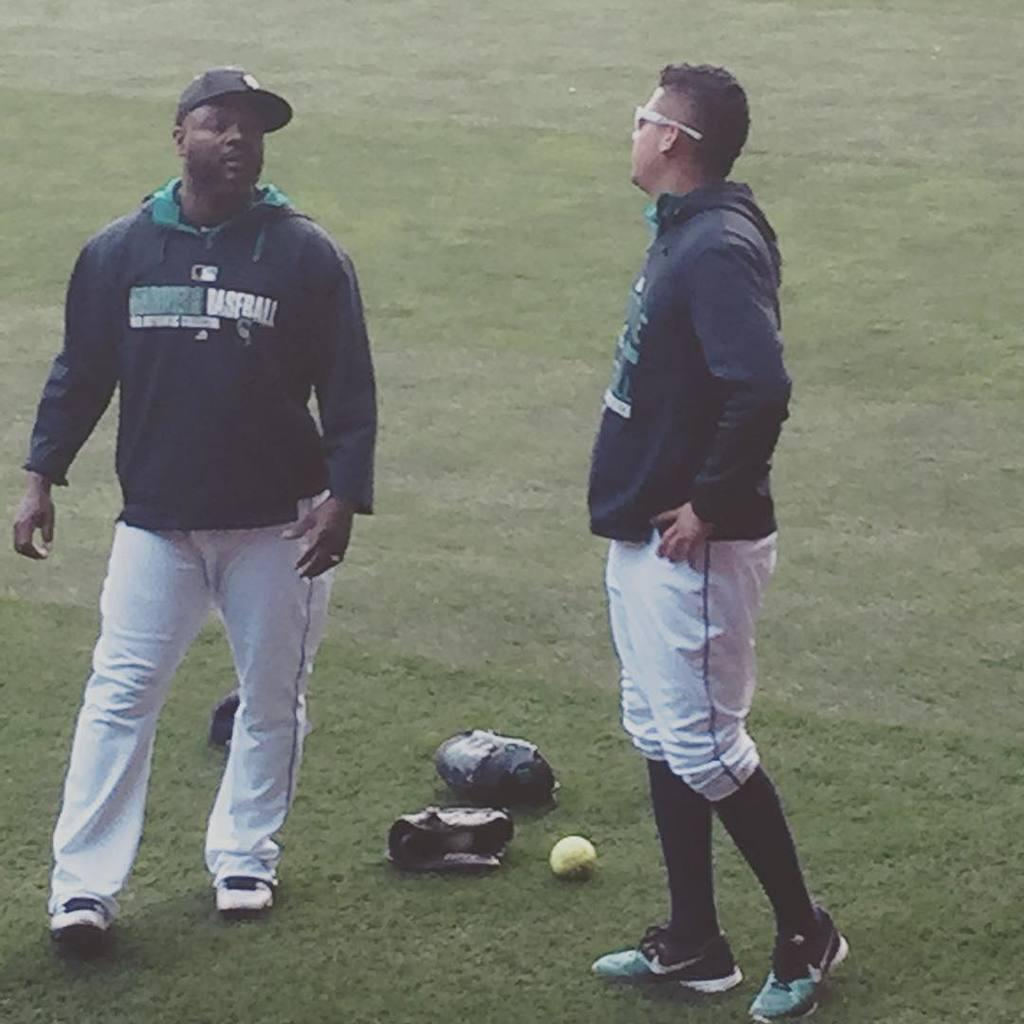Provide a one-sentence caption for the provided image. Two men are on the grass, one shirt has the word baseball. 